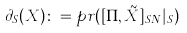<formula> <loc_0><loc_0><loc_500><loc_500>\partial _ { S } ( X ) \colon = p r ( [ \Pi , \tilde { X } ] _ { S N } | _ { S } )</formula> 